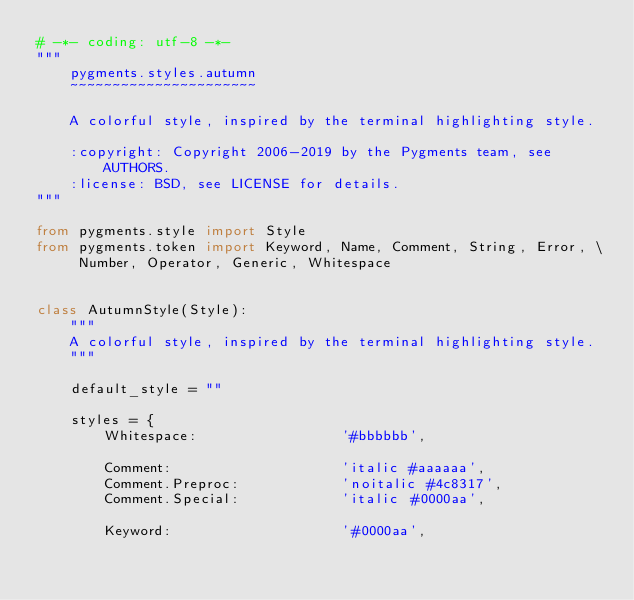<code> <loc_0><loc_0><loc_500><loc_500><_Python_># -*- coding: utf-8 -*-
"""
    pygments.styles.autumn
    ~~~~~~~~~~~~~~~~~~~~~~

    A colorful style, inspired by the terminal highlighting style.

    :copyright: Copyright 2006-2019 by the Pygments team, see AUTHORS.
    :license: BSD, see LICENSE for details.
"""

from pygments.style import Style
from pygments.token import Keyword, Name, Comment, String, Error, \
     Number, Operator, Generic, Whitespace


class AutumnStyle(Style):
    """
    A colorful style, inspired by the terminal highlighting style.
    """

    default_style = ""

    styles = {
        Whitespace:                 '#bbbbbb',

        Comment:                    'italic #aaaaaa',
        Comment.Preproc:            'noitalic #4c8317',
        Comment.Special:            'italic #0000aa',

        Keyword:                    '#0000aa',</code> 